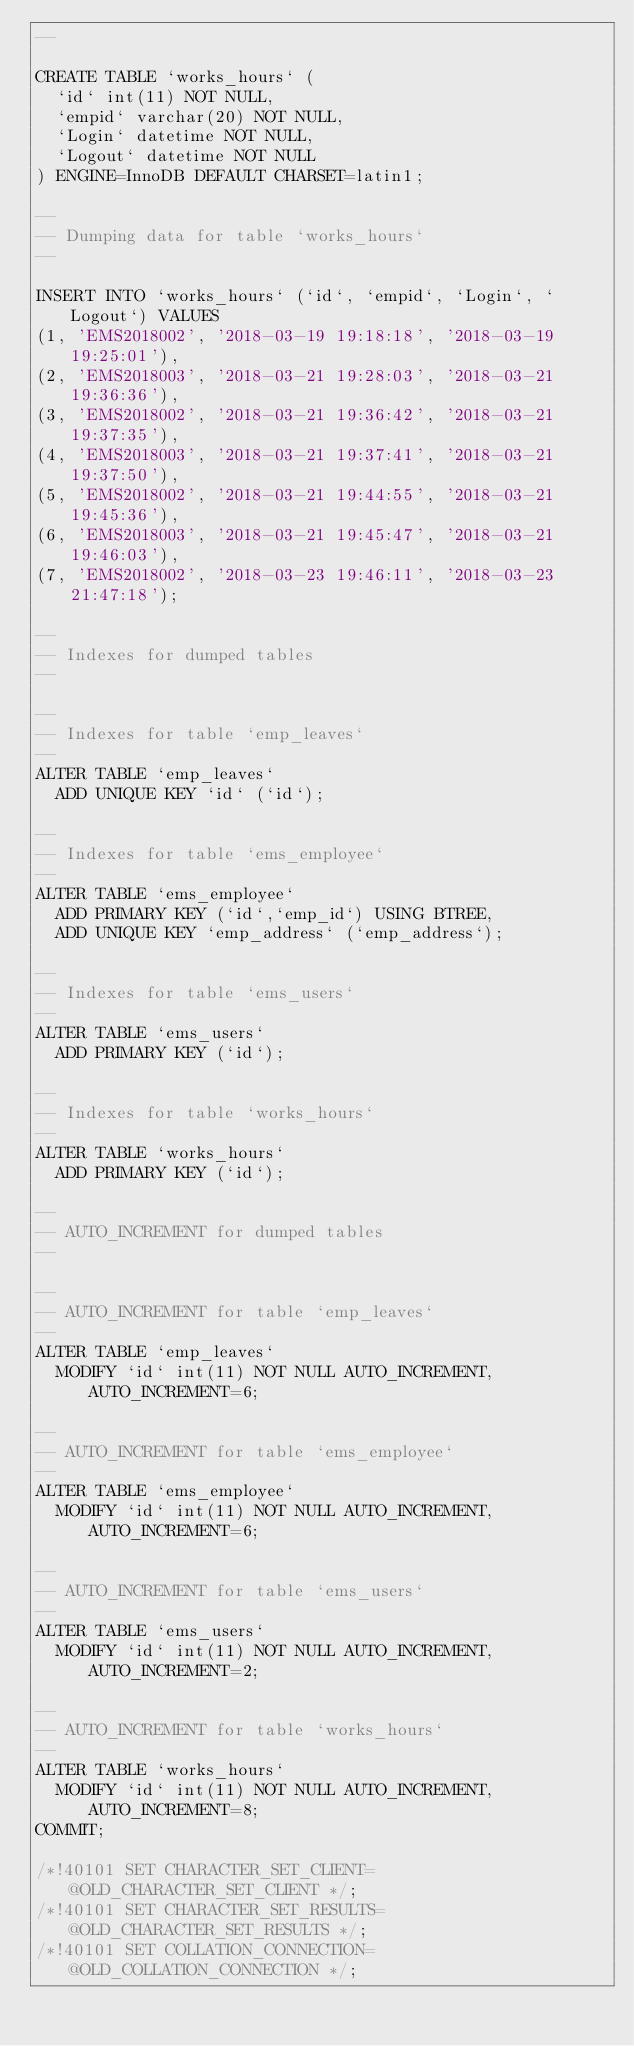<code> <loc_0><loc_0><loc_500><loc_500><_SQL_>--

CREATE TABLE `works_hours` (
  `id` int(11) NOT NULL,
  `empid` varchar(20) NOT NULL,
  `Login` datetime NOT NULL,
  `Logout` datetime NOT NULL
) ENGINE=InnoDB DEFAULT CHARSET=latin1;

--
-- Dumping data for table `works_hours`
--

INSERT INTO `works_hours` (`id`, `empid`, `Login`, `Logout`) VALUES
(1, 'EMS2018002', '2018-03-19 19:18:18', '2018-03-19 19:25:01'),
(2, 'EMS2018003', '2018-03-21 19:28:03', '2018-03-21 19:36:36'),
(3, 'EMS2018002', '2018-03-21 19:36:42', '2018-03-21 19:37:35'),
(4, 'EMS2018003', '2018-03-21 19:37:41', '2018-03-21 19:37:50'),
(5, 'EMS2018002', '2018-03-21 19:44:55', '2018-03-21 19:45:36'),
(6, 'EMS2018003', '2018-03-21 19:45:47', '2018-03-21 19:46:03'),
(7, 'EMS2018002', '2018-03-23 19:46:11', '2018-03-23 21:47:18');

--
-- Indexes for dumped tables
--

--
-- Indexes for table `emp_leaves`
--
ALTER TABLE `emp_leaves`
  ADD UNIQUE KEY `id` (`id`);

--
-- Indexes for table `ems_employee`
--
ALTER TABLE `ems_employee`
  ADD PRIMARY KEY (`id`,`emp_id`) USING BTREE,
  ADD UNIQUE KEY `emp_address` (`emp_address`);

--
-- Indexes for table `ems_users`
--
ALTER TABLE `ems_users`
  ADD PRIMARY KEY (`id`);

--
-- Indexes for table `works_hours`
--
ALTER TABLE `works_hours`
  ADD PRIMARY KEY (`id`);

--
-- AUTO_INCREMENT for dumped tables
--

--
-- AUTO_INCREMENT for table `emp_leaves`
--
ALTER TABLE `emp_leaves`
  MODIFY `id` int(11) NOT NULL AUTO_INCREMENT, AUTO_INCREMENT=6;

--
-- AUTO_INCREMENT for table `ems_employee`
--
ALTER TABLE `ems_employee`
  MODIFY `id` int(11) NOT NULL AUTO_INCREMENT, AUTO_INCREMENT=6;

--
-- AUTO_INCREMENT for table `ems_users`
--
ALTER TABLE `ems_users`
  MODIFY `id` int(11) NOT NULL AUTO_INCREMENT, AUTO_INCREMENT=2;

--
-- AUTO_INCREMENT for table `works_hours`
--
ALTER TABLE `works_hours`
  MODIFY `id` int(11) NOT NULL AUTO_INCREMENT, AUTO_INCREMENT=8;
COMMIT;

/*!40101 SET CHARACTER_SET_CLIENT=@OLD_CHARACTER_SET_CLIENT */;
/*!40101 SET CHARACTER_SET_RESULTS=@OLD_CHARACTER_SET_RESULTS */;
/*!40101 SET COLLATION_CONNECTION=@OLD_COLLATION_CONNECTION */;
</code> 